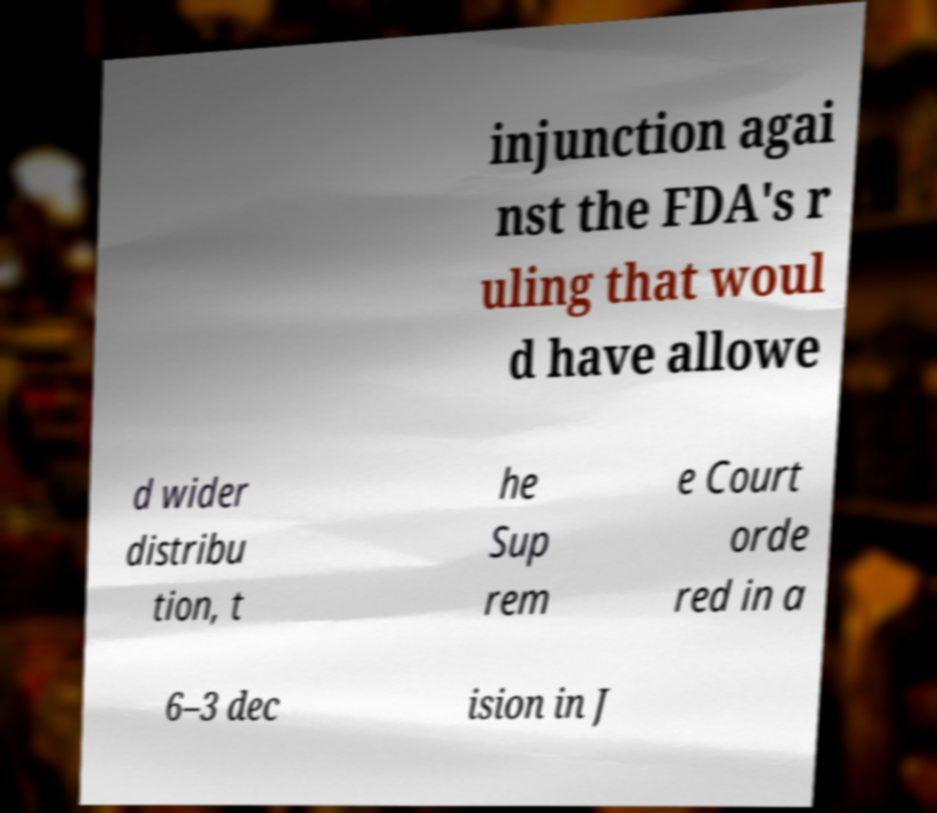For documentation purposes, I need the text within this image transcribed. Could you provide that? injunction agai nst the FDA's r uling that woul d have allowe d wider distribu tion, t he Sup rem e Court orde red in a 6–3 dec ision in J 